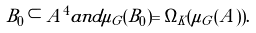<formula> <loc_0><loc_0><loc_500><loc_500>B _ { 0 } \subset A ^ { 4 } a n d \mu _ { G } ( B _ { 0 } ) = \Omega _ { K } ( \mu _ { G } ( A ) ) .</formula> 